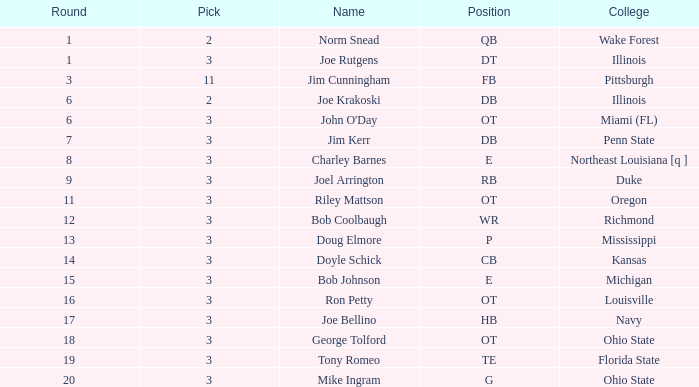How many instances are there where john o'day carries the name and has a pick under 3? None. 